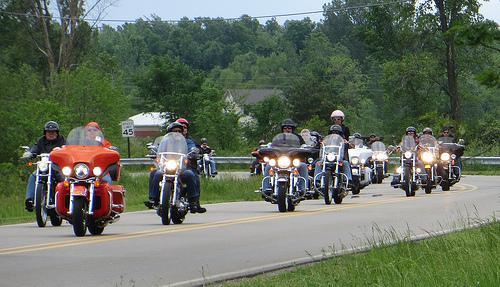Question: what vehicles are these?
Choices:
A. Cars.
B. Busses.
C. Scooters.
D. Motorcycles.
Answer with the letter. Answer: D Question: what are they wearing on their heads?
Choices:
A. Helmets.
B. Hats.
C. Caps.
D. Bandana.
Answer with the letter. Answer: A Question: where are the motorcycles?
Choices:
A. On the street.
B. On the road.
C. On the sidewalk.
D. In the garage.
Answer with the letter. Answer: B Question: what is in the distance?
Choices:
A. A barn and animals.
B. A mansion and pool.
C. A trailer and bike.
D. A house and trees.
Answer with the letter. Answer: D Question: who is on the road?
Choices:
A. Cyclists.
B. Drivers.
C. Motorcyclists.
D. Pedestrians.
Answer with the letter. Answer: C 